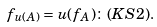<formula> <loc_0><loc_0><loc_500><loc_500>f _ { u ( A ) } = u ( f _ { A } ) \colon ( K S 2 ) .</formula> 